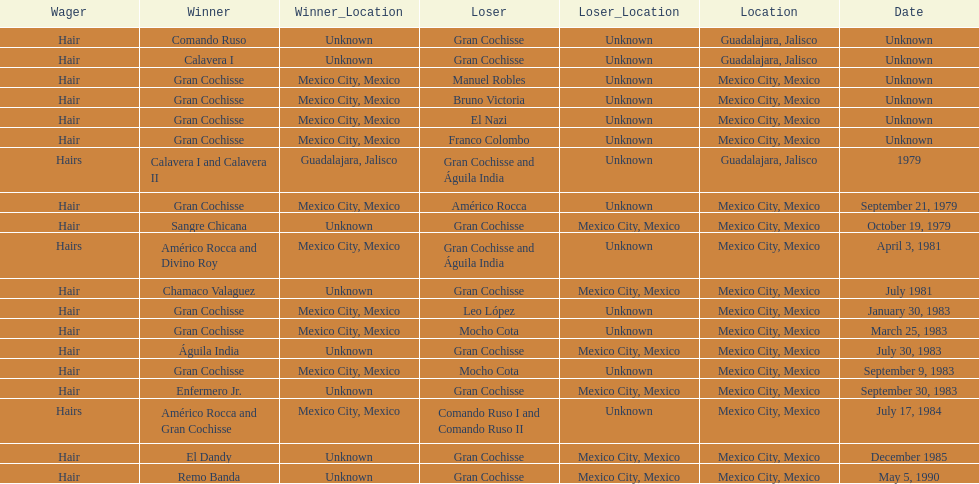When did bruno victoria lose his first game? Unknown. 